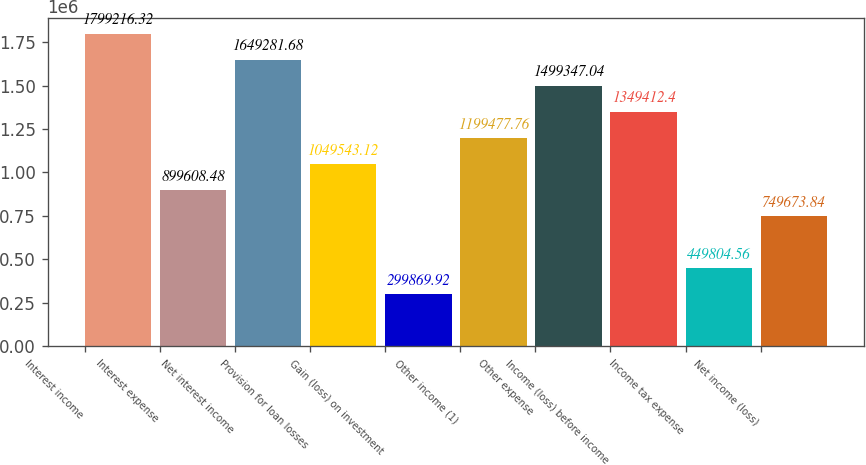Convert chart to OTSL. <chart><loc_0><loc_0><loc_500><loc_500><bar_chart><fcel>Interest income<fcel>Interest expense<fcel>Net interest income<fcel>Provision for loan losses<fcel>Gain (loss) on investment<fcel>Other income (1)<fcel>Other expense<fcel>Income (loss) before income<fcel>Income tax expense<fcel>Net income (loss)<nl><fcel>1.79922e+06<fcel>899608<fcel>1.64928e+06<fcel>1.04954e+06<fcel>299870<fcel>1.19948e+06<fcel>1.49935e+06<fcel>1.34941e+06<fcel>449805<fcel>749674<nl></chart> 